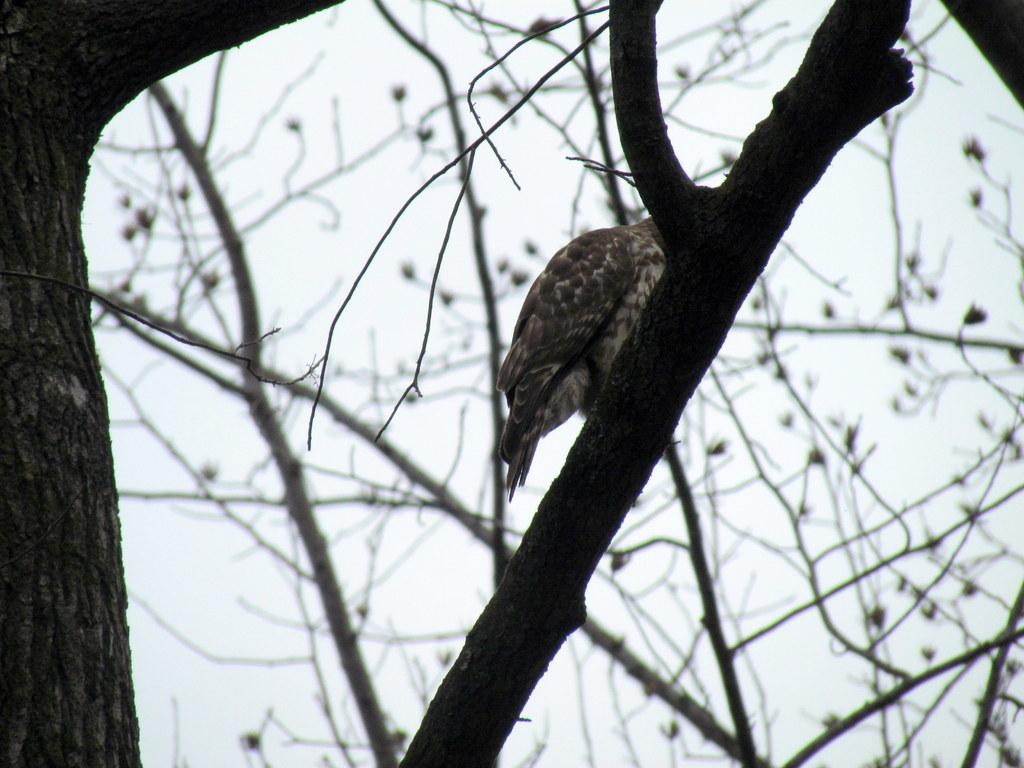Where was the image taken? The image was taken outdoors. What can be seen in the image besides the outdoor setting? There is a tree and a bird on a branch in the image. What type of soup is being served in the image? There is no soup present in the image; it features a tree and a bird on a branch outdoors. 